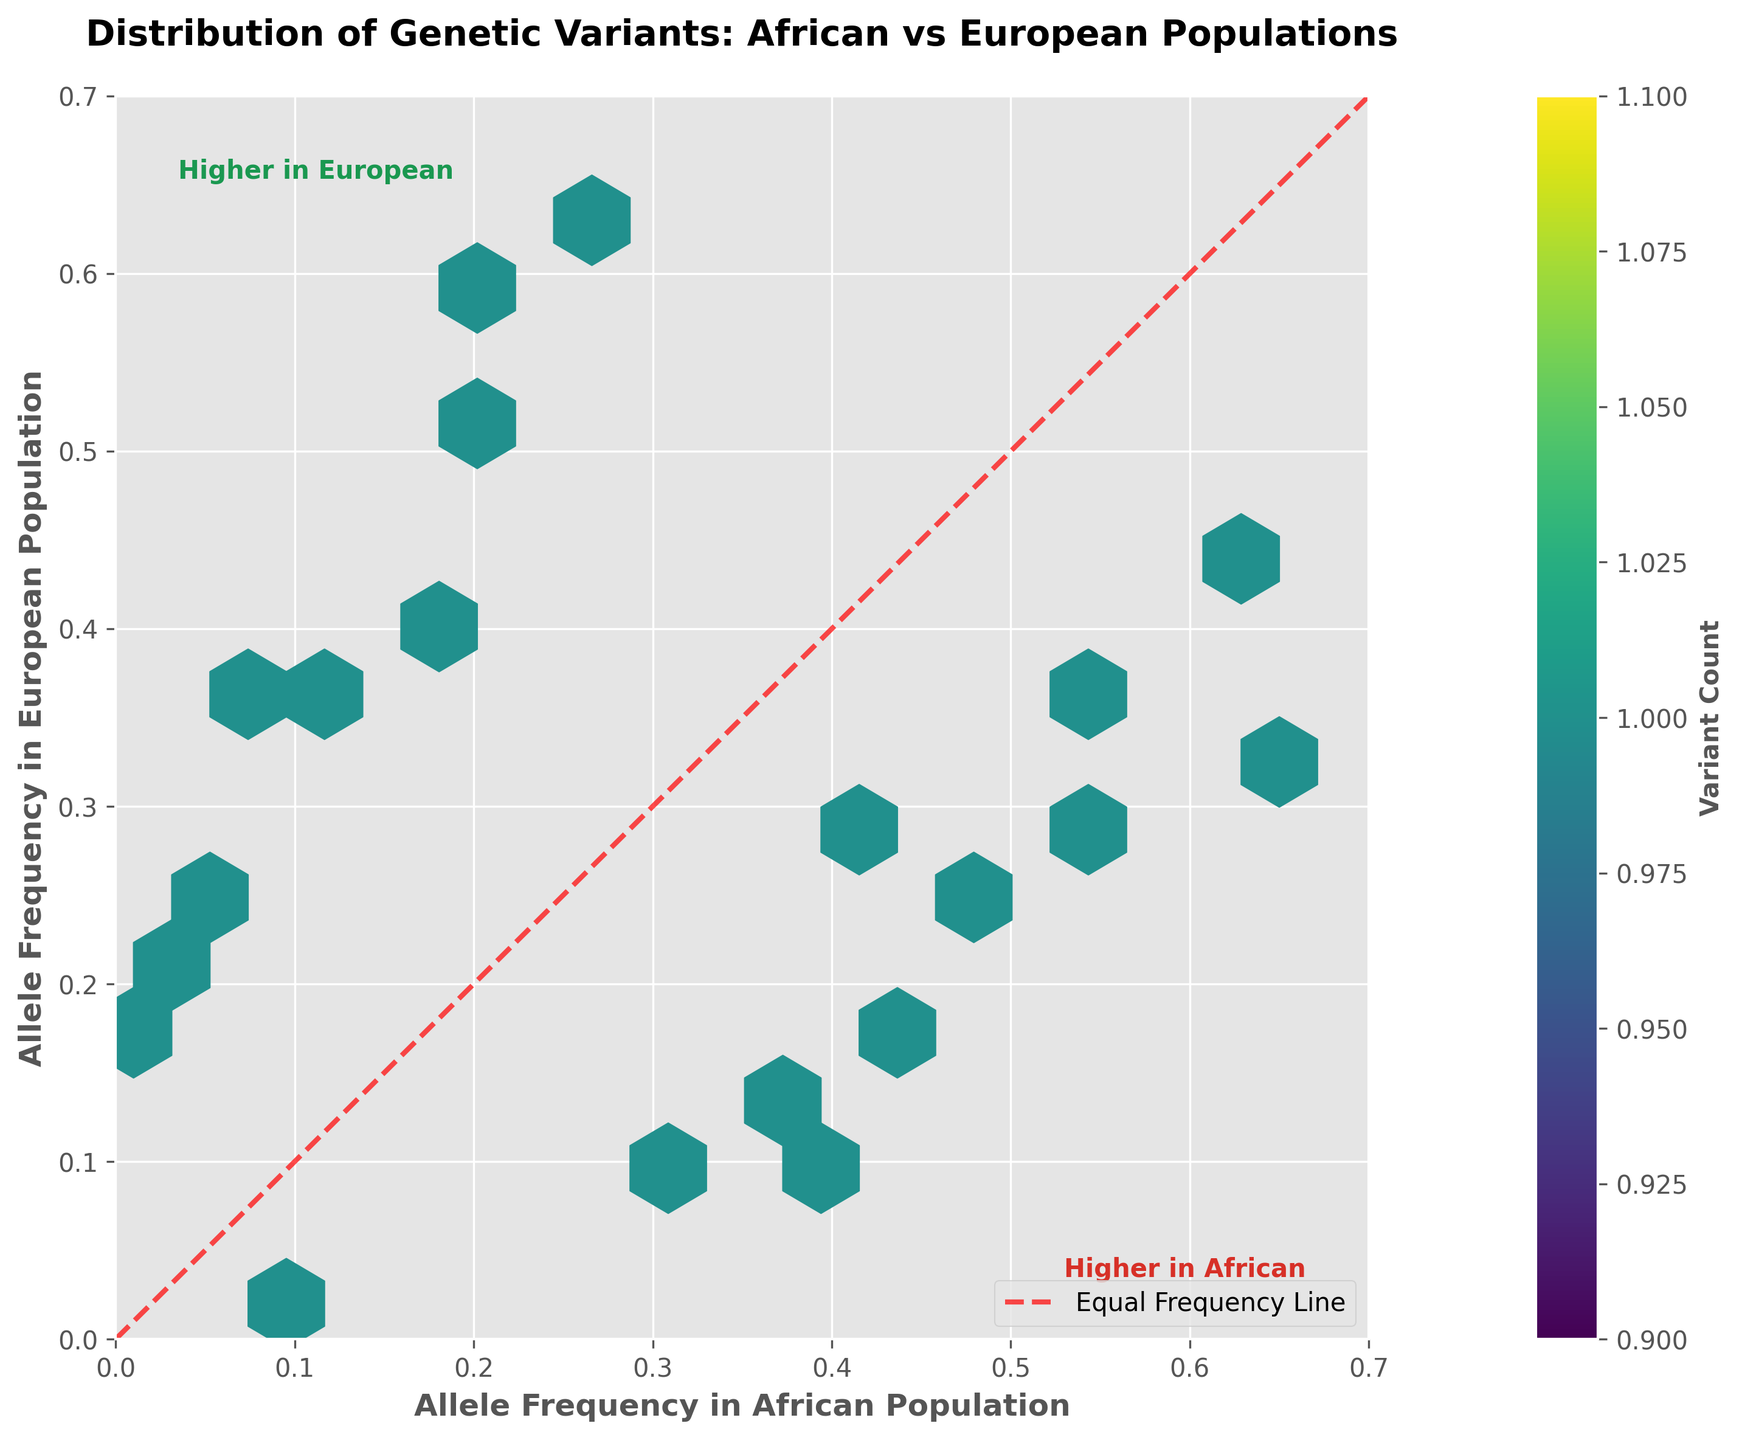1. What is the title of the figure? The title of the figure is located at the top of the plot and is typically written in a larger, bold font for visibility.
Answer: Distribution of Genetic Variants: African vs European Populations 2. What are the x and y axes labeled? The x and y labels are usually positioned along the axes to indicate what each axis represents. The x-axis represents the allele frequency in the African population, and the y-axis represents the allele frequency in the European population.
Answer: Allele Frequency in African Population; Allele Frequency in European Population 3. What does the color gradient represent in the hexbin plot? The color gradient in a hexbin plot typically indicates the density or count of data points within each hexagonal bin. The color bar positioned alongside the plot specifies the meaning of the gradient.
Answer: Variant Count 4. How many hexagons have the highest density of genetic variants? The hexbin plot's color bar allows us to identify the color corresponding to the highest variant count. By locating this color on the plot, we can count the number of hexagons with this density.
Answer: Only a few 5. Where on the plot are the allele frequencies higher in African populations? The plot's diagonal red dashed line represents equal allele frequencies between populations. Allele frequencies higher in African populations are shown on the right side of this line. This is visually indicated by higher counts of hexagons on the right side compared to the left.
Answer: Below the diagonal and to the right 6. Which allele frequency between African and European populations has more variance? Variance can be visually estimated by noting the spread of the hexagons along each axis. Greater spread indicates higher variance.
Answer: African population 7. Are there more genetic variants with higher allele frequencies in Europeans or Africans? By examining the distribution of hexagons relative to the red dashed line, we can determine which side generally contains more concentrated hexagons.
Answer: Europeans 8. What specific colors are indicated to represent regions with higher allele frequencies in African and European populations? Text labels placed at the borders of the plot provide the information. The color text '#d73027' indicates higher in African, while '#1a9850' indicates higher in European.
Answer: Higher in African: Red (#d73027); Higher in European: Green (#1a9850) 9. Do we observe any genetic variants with equal allele frequencies in both populations? Variants with equal allele frequencies in both populations lie along the red dashed line. By inspecting along this line, we can check for data points.
Answer: No 10. What is the grid size used in the hexbin plot? This information can be inferred from the visual density of the hexagons across the plot. Fewer hexagons indicate a larger grid size, while more hexagons suggest a smaller grid size.
Answer: 15 